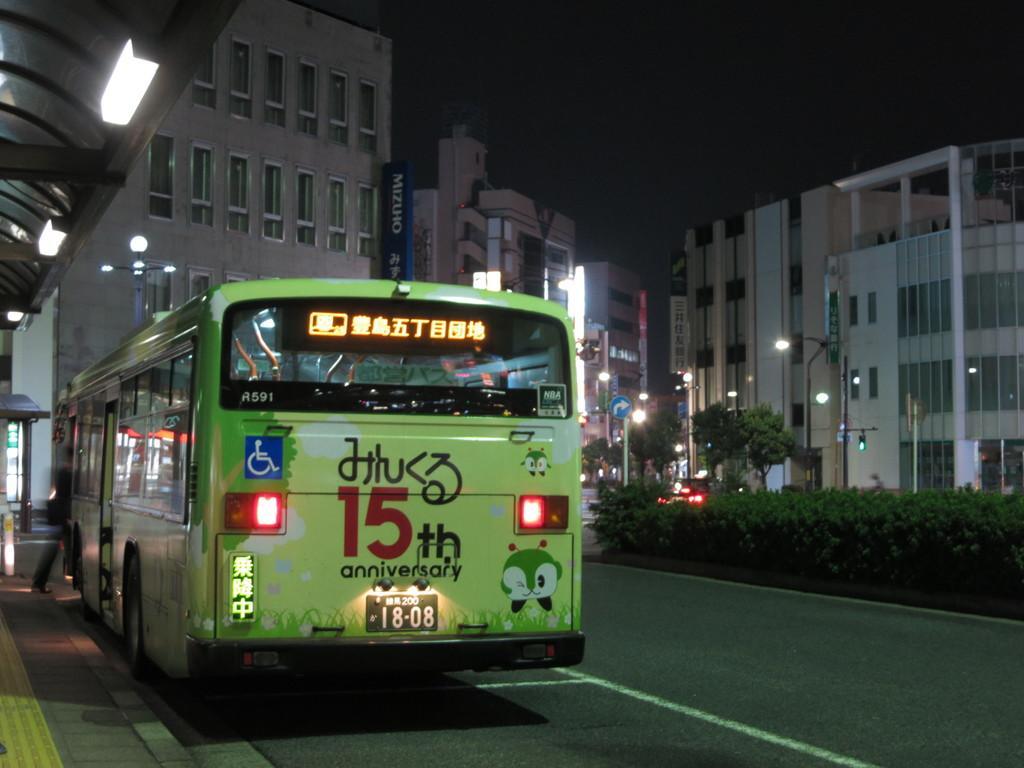In one or two sentences, can you explain what this image depicts? This picture might be taken outside of a city, in this image on the left side there is a bus. And in the background there are buildings, trees, poles, lights, and at the bottom there is road. And on the left side of the image there is one person and in the top left hand corner there are lights and some board. At the top there is sky. 